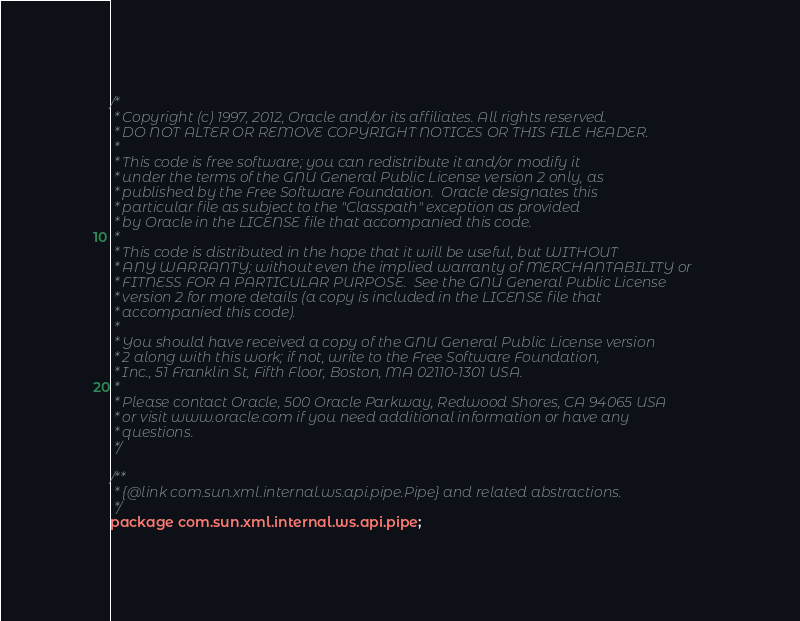<code> <loc_0><loc_0><loc_500><loc_500><_Java_>/*
 * Copyright (c) 1997, 2012, Oracle and/or its affiliates. All rights reserved.
 * DO NOT ALTER OR REMOVE COPYRIGHT NOTICES OR THIS FILE HEADER.
 *
 * This code is free software; you can redistribute it and/or modify it
 * under the terms of the GNU General Public License version 2 only, as
 * published by the Free Software Foundation.  Oracle designates this
 * particular file as subject to the "Classpath" exception as provided
 * by Oracle in the LICENSE file that accompanied this code.
 *
 * This code is distributed in the hope that it will be useful, but WITHOUT
 * ANY WARRANTY; without even the implied warranty of MERCHANTABILITY or
 * FITNESS FOR A PARTICULAR PURPOSE.  See the GNU General Public License
 * version 2 for more details (a copy is included in the LICENSE file that
 * accompanied this code).
 *
 * You should have received a copy of the GNU General Public License version
 * 2 along with this work; if not, write to the Free Software Foundation,
 * Inc., 51 Franklin St, Fifth Floor, Boston, MA 02110-1301 USA.
 *
 * Please contact Oracle, 500 Oracle Parkway, Redwood Shores, CA 94065 USA
 * or visit www.oracle.com if you need additional information or have any
 * questions.
 */

/**
 * {@link com.sun.xml.internal.ws.api.pipe.Pipe} and related abstractions.
 */
package com.sun.xml.internal.ws.api.pipe;
</code> 